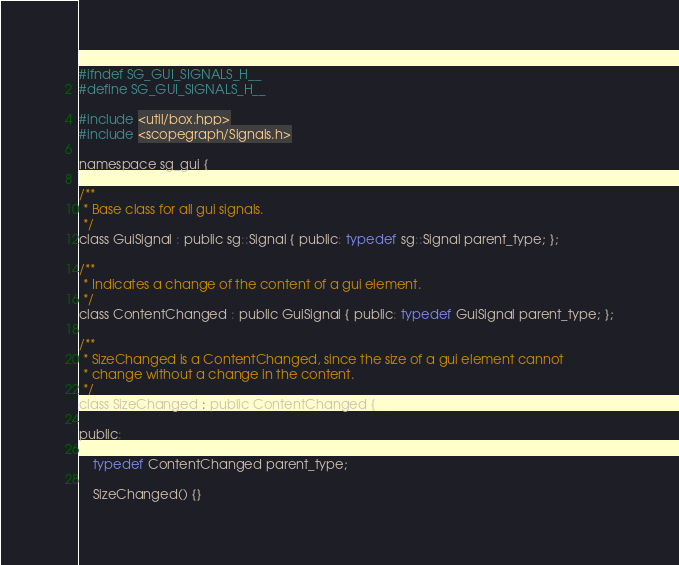<code> <loc_0><loc_0><loc_500><loc_500><_C_>#ifndef SG_GUI_SIGNALS_H__
#define SG_GUI_SIGNALS_H__

#include <util/box.hpp>
#include <scopegraph/Signals.h>

namespace sg_gui {

/**
 * Base class for all gui signals.
 */
class GuiSignal : public sg::Signal { public: typedef sg::Signal parent_type; };

/**
 * Indicates a change of the content of a gui element.
 */
class ContentChanged : public GuiSignal { public: typedef GuiSignal parent_type; };

/**
 * SizeChanged is a ContentChanged, since the size of a gui element cannot
 * change without a change in the content.
 */
class SizeChanged : public ContentChanged {

public:

	typedef ContentChanged parent_type;

	SizeChanged() {}
</code> 